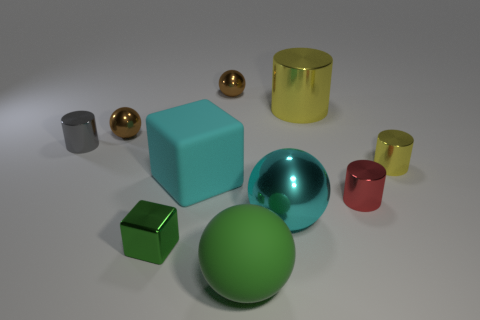Is the rubber cube the same color as the big metallic ball?
Provide a short and direct response. Yes. There is a cube that is made of the same material as the big green thing; what is its color?
Your answer should be very brief. Cyan. Is there a large yellow metallic thing that is on the right side of the big matte object that is on the left side of the green matte sphere?
Keep it short and to the point. Yes. How many other things are there of the same shape as the big green rubber object?
Offer a terse response. 3. There is a yellow object that is in front of the gray object; is its shape the same as the gray thing behind the small green object?
Ensure brevity in your answer.  Yes. How many brown shiny spheres are behind the big cyan object that is in front of the metallic cylinder in front of the matte cube?
Offer a terse response. 2. What is the color of the small cube?
Provide a succinct answer. Green. How many other objects are there of the same size as the cyan shiny thing?
Offer a very short reply. 3. There is a small red object that is the same shape as the gray shiny object; what is its material?
Your answer should be compact. Metal. What material is the brown sphere that is on the right side of the tiny brown metallic thing that is left of the brown metallic thing that is right of the large cyan rubber cube?
Your response must be concise. Metal. 